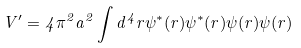<formula> <loc_0><loc_0><loc_500><loc_500>V ^ { \prime } = 4 \pi ^ { 2 } a ^ { 2 } \int d ^ { 4 } r \psi ^ { * } ( r ) \psi ^ { * } ( r ) \psi ( r ) \psi ( r )</formula> 